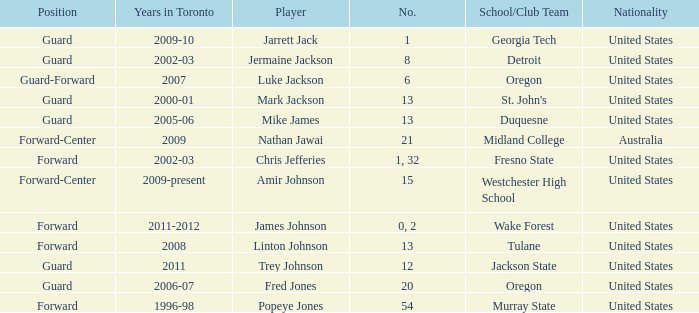What school/club team is Trey Johnson on? Jackson State. Parse the full table. {'header': ['Position', 'Years in Toronto', 'Player', 'No.', 'School/Club Team', 'Nationality'], 'rows': [['Guard', '2009-10', 'Jarrett Jack', '1', 'Georgia Tech', 'United States'], ['Guard', '2002-03', 'Jermaine Jackson', '8', 'Detroit', 'United States'], ['Guard-Forward', '2007', 'Luke Jackson', '6', 'Oregon', 'United States'], ['Guard', '2000-01', 'Mark Jackson', '13', "St. John's", 'United States'], ['Guard', '2005-06', 'Mike James', '13', 'Duquesne', 'United States'], ['Forward-Center', '2009', 'Nathan Jawai', '21', 'Midland College', 'Australia'], ['Forward', '2002-03', 'Chris Jefferies', '1, 32', 'Fresno State', 'United States'], ['Forward-Center', '2009-present', 'Amir Johnson', '15', 'Westchester High School', 'United States'], ['Forward', '2011-2012', 'James Johnson', '0, 2', 'Wake Forest', 'United States'], ['Forward', '2008', 'Linton Johnson', '13', 'Tulane', 'United States'], ['Guard', '2011', 'Trey Johnson', '12', 'Jackson State', 'United States'], ['Guard', '2006-07', 'Fred Jones', '20', 'Oregon', 'United States'], ['Forward', '1996-98', 'Popeye Jones', '54', 'Murray State', 'United States']]} 